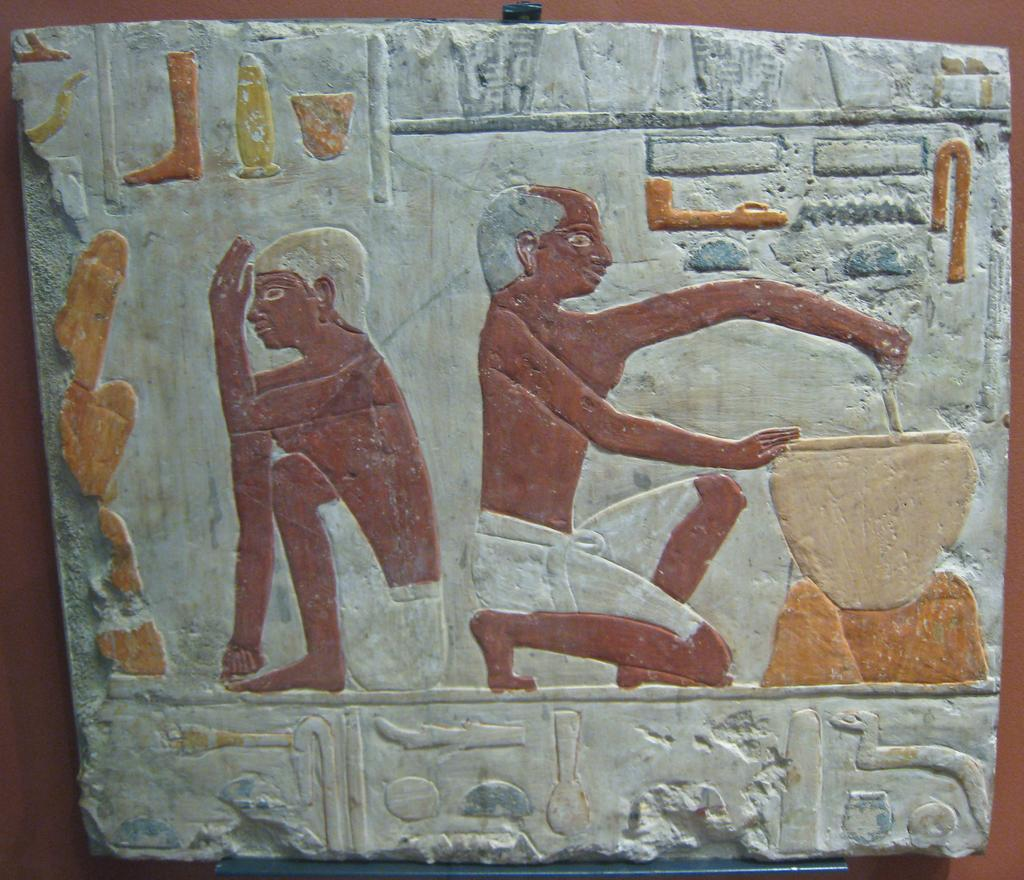What is the main subject in the foreground of the image? There is a board in the foreground of the image. What is placed on the board? There are objects on the board. What can be seen in the background of the image? There is a wall in the background of the image. What type of books are being read by the team in the image? There is no team or books present in the image; it only features a board with objects on it and a wall in the background. 